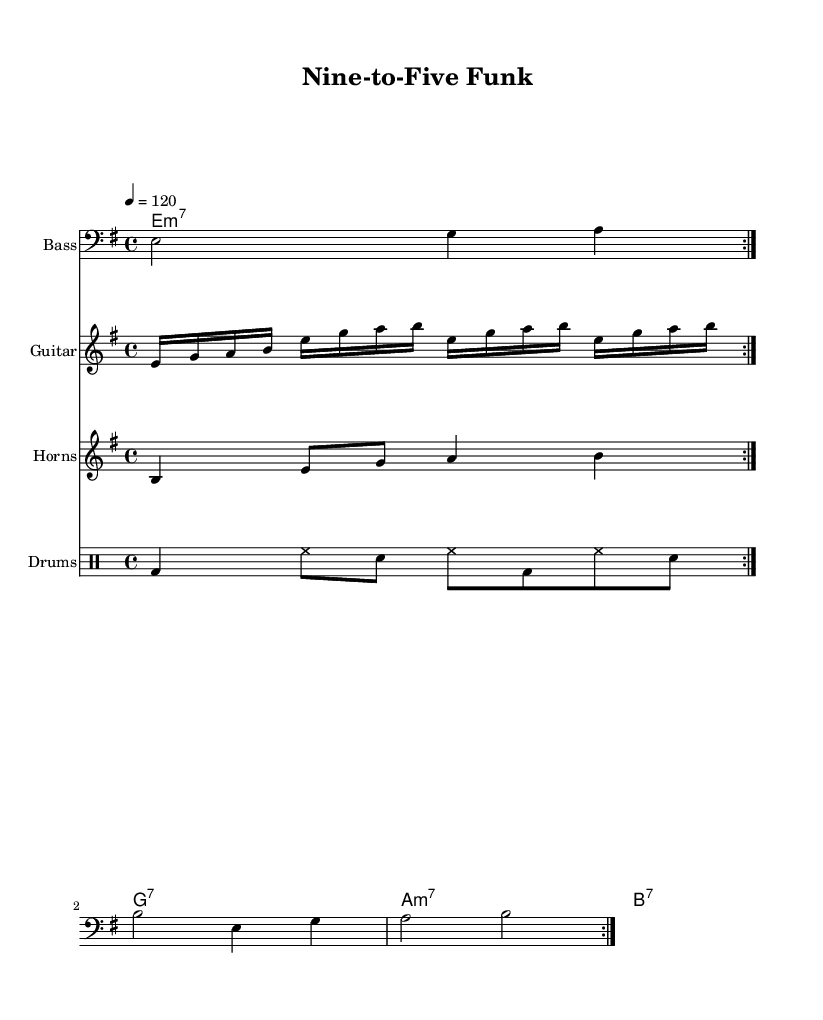What is the key signature of this music? The key signature is E minor, which includes one sharp (F#) and indicates that the piece is in E minor.
Answer: E minor What is the time signature of this piece? The time signature is 4/4, meaning there are four beats in each measure and the quarter note receives one beat.
Answer: 4/4 What is the tempo of the music? The tempo marking indicates 120 beats per minute, which suggests a moderate pace for the performance.
Answer: 120 How many measures does the bass line repeat? The bass line is marked with "volta 2", indicating it repeats two times before moving to the next section of the music.
Answer: 2 What instruments are included in this score? The score includes bass, guitar, horns, and drums, reflecting the typical instrumentation found in funk music ensembles.
Answer: Bass, guitar, horns, drums What kind of chords are indicated for the clavinet? The chords listed for the clavinet are minor and dominant seventh chords, which are characteristic of the funk genre and contribute to its rhythmic and harmonic complexity.
Answer: Minor and dominant seventh What is the rhythmic pattern used in the drum section? The drum pattern consists of a bass drum, hi-hat, and snare played in a repetitive structure, creating a steady groove typical of funk music.
Answer: Bass, hi-hat, snare 